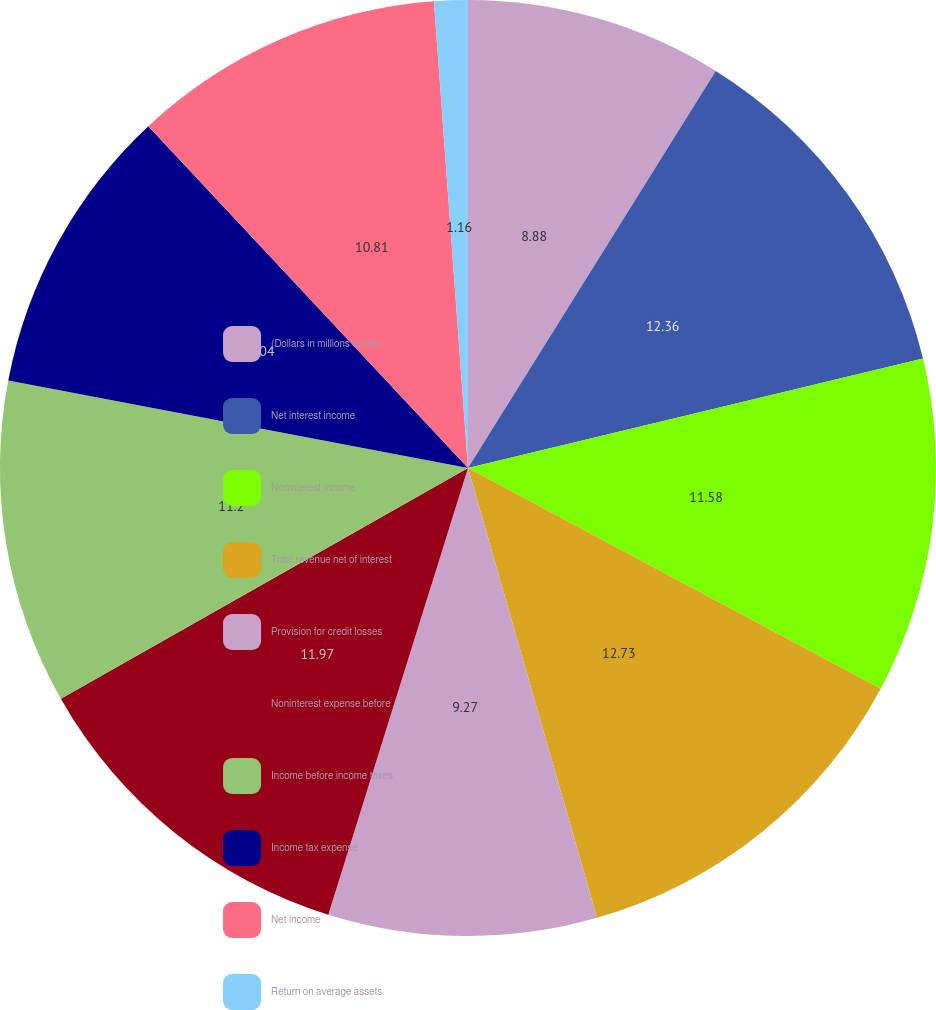<chart> <loc_0><loc_0><loc_500><loc_500><pie_chart><fcel>(Dollars in millions except<fcel>Net interest income<fcel>Noninterest income<fcel>Total revenue net of interest<fcel>Provision for credit losses<fcel>Noninterest expense before<fcel>Income before income taxes<fcel>Income tax expense<fcel>Net income<fcel>Return on average assets<nl><fcel>8.88%<fcel>12.36%<fcel>11.58%<fcel>12.74%<fcel>9.27%<fcel>11.97%<fcel>11.2%<fcel>10.04%<fcel>10.81%<fcel>1.16%<nl></chart> 